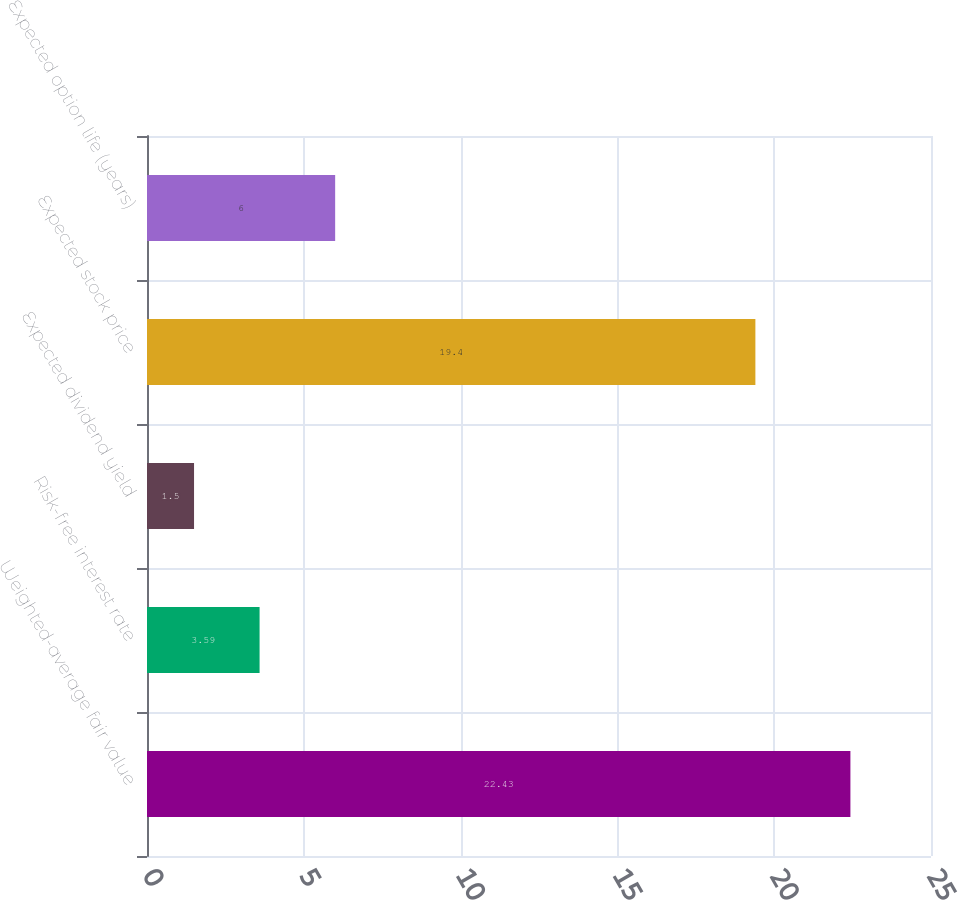<chart> <loc_0><loc_0><loc_500><loc_500><bar_chart><fcel>Weighted-average fair value<fcel>Risk-free interest rate<fcel>Expected dividend yield<fcel>Expected stock price<fcel>Expected option life (years)<nl><fcel>22.43<fcel>3.59<fcel>1.5<fcel>19.4<fcel>6<nl></chart> 